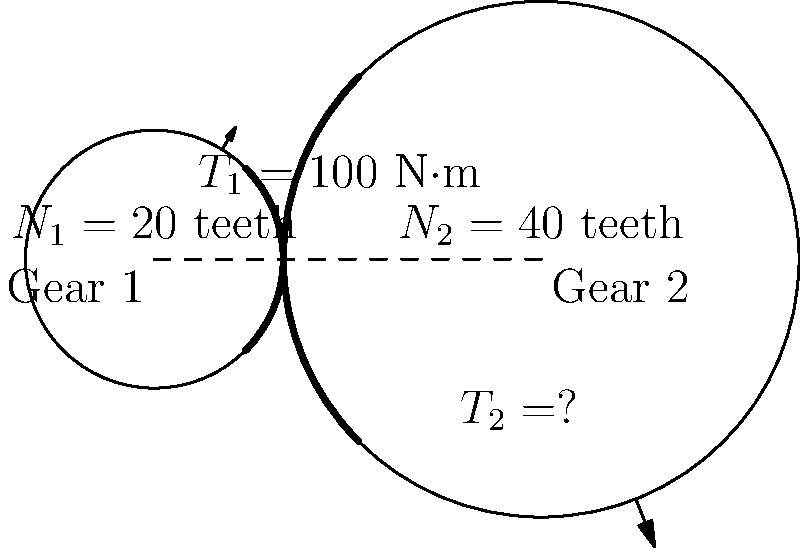In this simple gear train, Gear 1 has 20 teeth and Gear 2 has 40 teeth. If a torque of 100 N·m is applied to Gear 1, what is the output torque (T₂) on Gear 2, assuming no losses in the system? How does this relate to the gear ratio and the writer's ability to create engaging mechanical scenarios? Let's approach this step-by-step, imagining we're characters in a well-crafted engineering tale:

1) First, we need to determine the gear ratio. The gear ratio is the ratio of the number of teeth on the output gear to the number of teeth on the input gear:

   Gear Ratio = $\frac{N_2}{N_1} = \frac{40}{20} = 2$

2) In an ideal gear train with no losses, the principle of conservation of energy applies. This means that the input power equals the output power:

   $P_{in} = P_{out}$

3) Power is the product of torque and angular velocity. Since power is conserved:

   $T_1 \omega_1 = T_2 \omega_2$

4) The angular velocities are inversely proportional to the number of teeth:

   $\frac{\omega_1}{\omega_2} = \frac{N_2}{N_1} = 2$

5) Substituting this into the power equation:

   $T_1 (2\omega_2) = T_2 \omega_2$

6) Simplifying:

   $2T_1 = T_2$

7) Now we can calculate T₂:

   $T_2 = 2 \times 100 = 200$ N·m

This scenario showcases how a writer can create an engaging mechanical puzzle. The interplay between the gear sizes and the resulting torque amplification mirrors the way a skilled author can take a simple concept and magnify its impact through clever storytelling.
Answer: 200 N·m 